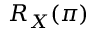<formula> <loc_0><loc_0><loc_500><loc_500>R _ { X } ( \pi )</formula> 